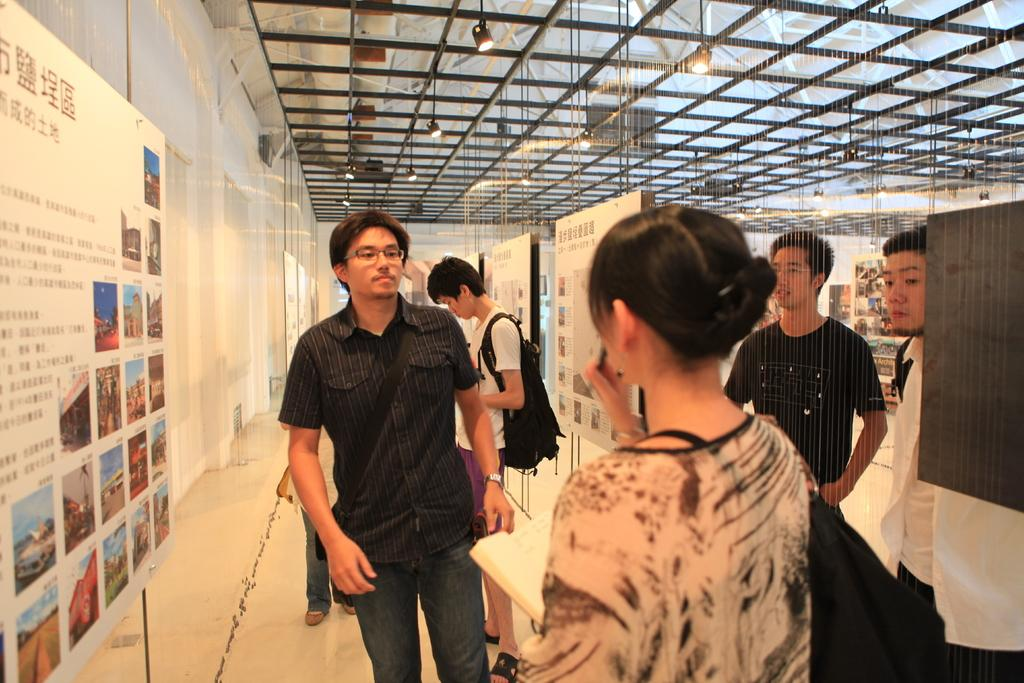What is one of the main features in the image? There is a wall in the image. What else can be seen hanging on the wall? There is a banner in the image. Are there any people present in the image? Yes, there are people in the image. What is a woman in the image holding? A woman is holding a book in the image. Can you describe the appearance of one of the people in the image? A person is wearing a black color bag in the image. What type of behavior can be observed in the truck in the image? There is no truck present in the image, so it is not possible to observe any behavior in a truck. 